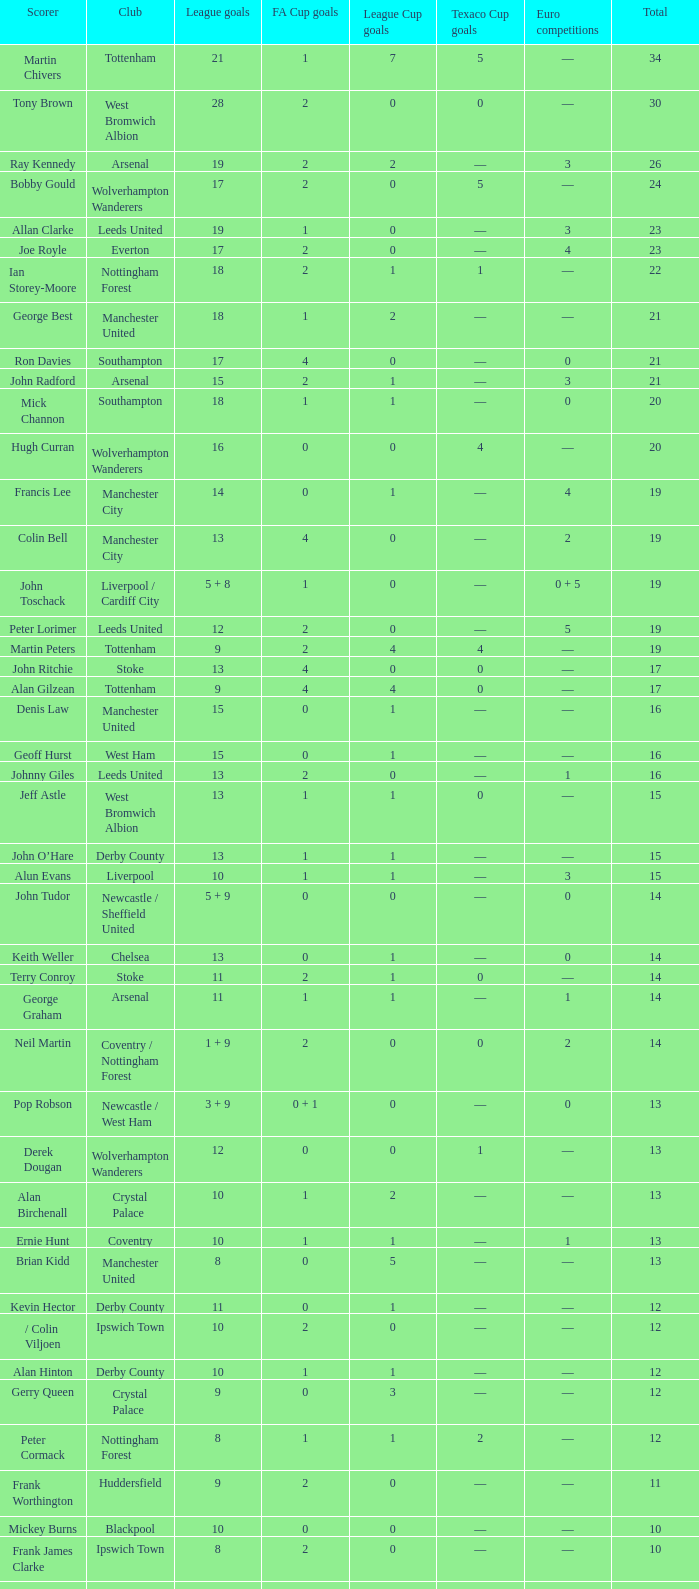What is the least amount of league cup goals made by denis law? 1.0. 